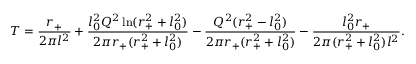<formula> <loc_0><loc_0><loc_500><loc_500>T = \frac { r _ { + } } { 2 \pi l ^ { 2 } } + \frac { l _ { 0 } ^ { 2 } Q ^ { 2 } \ln ( r _ { + } ^ { 2 } + l _ { 0 } ^ { 2 } ) } { 2 \pi r _ { + } ( r _ { + } ^ { 2 } + l _ { 0 } ^ { 2 } ) } - \frac { Q ^ { 2 } ( r _ { + } ^ { 2 } - l _ { 0 } ^ { 2 } ) } { 2 \pi r _ { + } ( r _ { + } ^ { 2 } + l _ { 0 } ^ { 2 } ) } - \frac { l _ { 0 } ^ { 2 } r _ { + } } { 2 \pi ( r _ { + } ^ { 2 } + l _ { 0 } ^ { 2 } ) l ^ { 2 } } .</formula> 